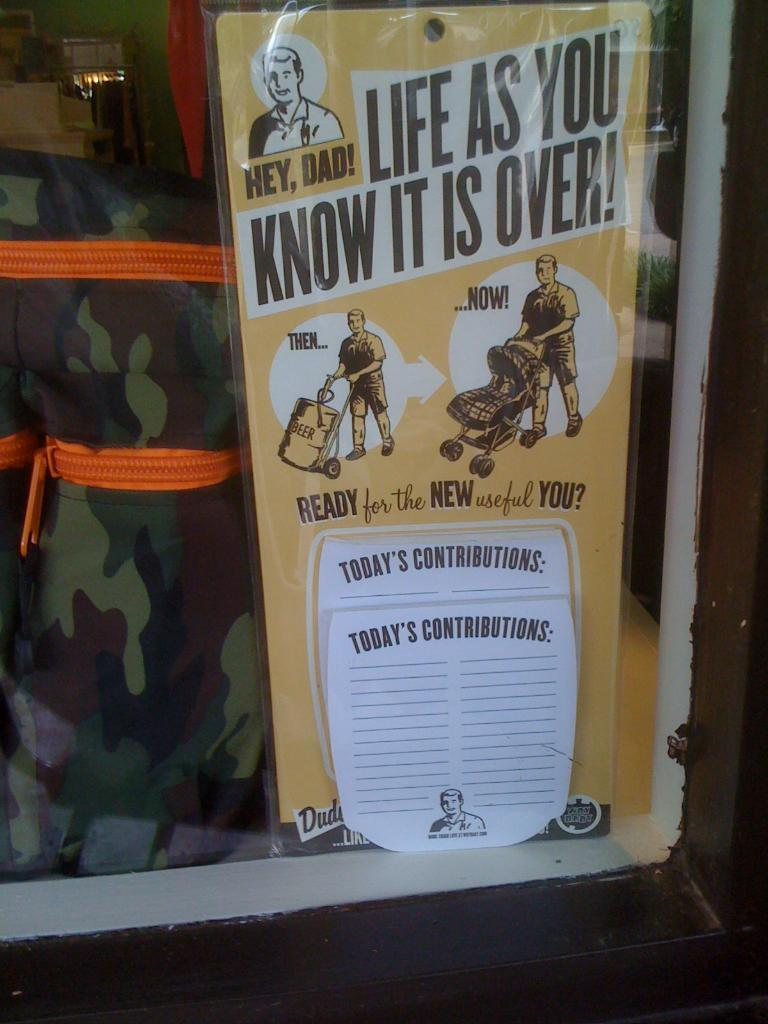Provide a one-sentence caption for the provided image. An advertisement shows a man pushing a beer keg with the label then and another with the man pushing a baby stroller and the label now. 